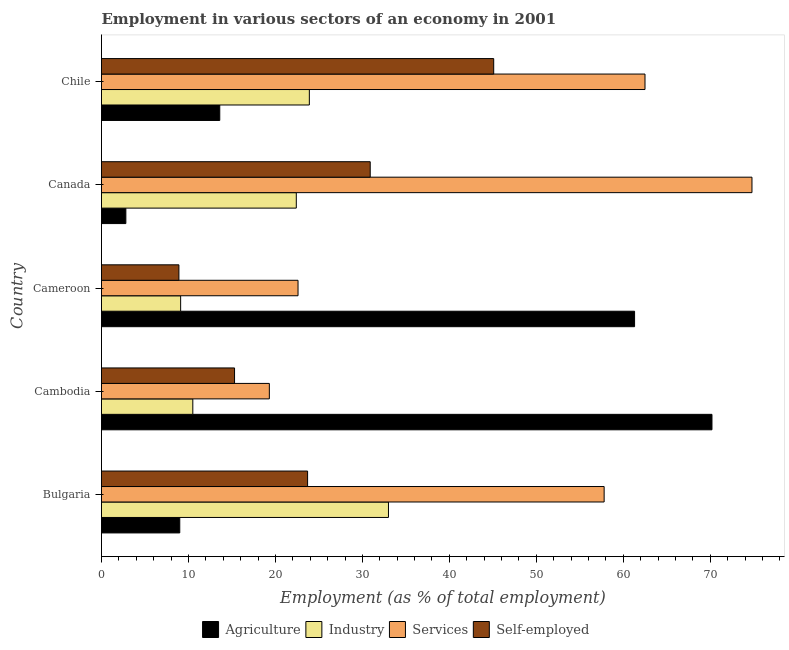How many groups of bars are there?
Your answer should be compact. 5. Are the number of bars per tick equal to the number of legend labels?
Your answer should be very brief. Yes. Are the number of bars on each tick of the Y-axis equal?
Provide a short and direct response. Yes. How many bars are there on the 2nd tick from the top?
Give a very brief answer. 4. In how many cases, is the number of bars for a given country not equal to the number of legend labels?
Your response must be concise. 0. What is the percentage of workers in industry in Cameroon?
Provide a succinct answer. 9.1. Across all countries, what is the minimum percentage of workers in services?
Keep it short and to the point. 19.3. In which country was the percentage of workers in services maximum?
Provide a succinct answer. Canada. What is the total percentage of self employed workers in the graph?
Give a very brief answer. 123.9. What is the difference between the percentage of self employed workers in Cambodia and that in Chile?
Your response must be concise. -29.8. What is the difference between the percentage of self employed workers in Cameroon and the percentage of workers in industry in Canada?
Provide a succinct answer. -13.5. What is the average percentage of self employed workers per country?
Your answer should be compact. 24.78. What is the difference between the percentage of self employed workers and percentage of workers in services in Bulgaria?
Your answer should be very brief. -34.1. In how many countries, is the percentage of workers in industry greater than 48 %?
Make the answer very short. 0. What is the ratio of the percentage of workers in industry in Cambodia to that in Canada?
Offer a very short reply. 0.47. Is the percentage of workers in services in Bulgaria less than that in Cambodia?
Your answer should be very brief. No. What is the difference between the highest and the second highest percentage of workers in industry?
Provide a short and direct response. 9.1. What is the difference between the highest and the lowest percentage of workers in agriculture?
Your answer should be very brief. 67.4. Is the sum of the percentage of workers in agriculture in Cambodia and Cameroon greater than the maximum percentage of workers in industry across all countries?
Offer a very short reply. Yes. What does the 3rd bar from the top in Cameroon represents?
Your answer should be very brief. Industry. What does the 4th bar from the bottom in Bulgaria represents?
Offer a terse response. Self-employed. Is it the case that in every country, the sum of the percentage of workers in agriculture and percentage of workers in industry is greater than the percentage of workers in services?
Your answer should be compact. No. How many bars are there?
Ensure brevity in your answer.  20. Are all the bars in the graph horizontal?
Offer a terse response. Yes. How many countries are there in the graph?
Offer a very short reply. 5. Does the graph contain any zero values?
Keep it short and to the point. No. Does the graph contain grids?
Provide a succinct answer. No. Where does the legend appear in the graph?
Make the answer very short. Bottom center. How many legend labels are there?
Offer a terse response. 4. How are the legend labels stacked?
Your answer should be compact. Horizontal. What is the title of the graph?
Offer a terse response. Employment in various sectors of an economy in 2001. What is the label or title of the X-axis?
Give a very brief answer. Employment (as % of total employment). What is the label or title of the Y-axis?
Your answer should be very brief. Country. What is the Employment (as % of total employment) of Agriculture in Bulgaria?
Your answer should be compact. 9. What is the Employment (as % of total employment) of Services in Bulgaria?
Provide a succinct answer. 57.8. What is the Employment (as % of total employment) of Self-employed in Bulgaria?
Keep it short and to the point. 23.7. What is the Employment (as % of total employment) of Agriculture in Cambodia?
Give a very brief answer. 70.2. What is the Employment (as % of total employment) in Industry in Cambodia?
Make the answer very short. 10.5. What is the Employment (as % of total employment) in Services in Cambodia?
Provide a succinct answer. 19.3. What is the Employment (as % of total employment) in Self-employed in Cambodia?
Provide a succinct answer. 15.3. What is the Employment (as % of total employment) of Agriculture in Cameroon?
Make the answer very short. 61.3. What is the Employment (as % of total employment) of Industry in Cameroon?
Give a very brief answer. 9.1. What is the Employment (as % of total employment) in Services in Cameroon?
Keep it short and to the point. 22.6. What is the Employment (as % of total employment) in Self-employed in Cameroon?
Your answer should be compact. 8.9. What is the Employment (as % of total employment) in Agriculture in Canada?
Make the answer very short. 2.8. What is the Employment (as % of total employment) in Industry in Canada?
Offer a very short reply. 22.4. What is the Employment (as % of total employment) of Services in Canada?
Make the answer very short. 74.8. What is the Employment (as % of total employment) of Self-employed in Canada?
Offer a terse response. 30.9. What is the Employment (as % of total employment) of Agriculture in Chile?
Ensure brevity in your answer.  13.6. What is the Employment (as % of total employment) in Industry in Chile?
Offer a very short reply. 23.9. What is the Employment (as % of total employment) in Services in Chile?
Ensure brevity in your answer.  62.5. What is the Employment (as % of total employment) in Self-employed in Chile?
Offer a very short reply. 45.1. Across all countries, what is the maximum Employment (as % of total employment) in Agriculture?
Make the answer very short. 70.2. Across all countries, what is the maximum Employment (as % of total employment) in Industry?
Provide a succinct answer. 33. Across all countries, what is the maximum Employment (as % of total employment) in Services?
Provide a short and direct response. 74.8. Across all countries, what is the maximum Employment (as % of total employment) in Self-employed?
Your answer should be compact. 45.1. Across all countries, what is the minimum Employment (as % of total employment) of Agriculture?
Ensure brevity in your answer.  2.8. Across all countries, what is the minimum Employment (as % of total employment) of Industry?
Offer a very short reply. 9.1. Across all countries, what is the minimum Employment (as % of total employment) of Services?
Make the answer very short. 19.3. Across all countries, what is the minimum Employment (as % of total employment) in Self-employed?
Provide a succinct answer. 8.9. What is the total Employment (as % of total employment) in Agriculture in the graph?
Keep it short and to the point. 156.9. What is the total Employment (as % of total employment) of Industry in the graph?
Provide a succinct answer. 98.9. What is the total Employment (as % of total employment) of Services in the graph?
Your answer should be very brief. 237. What is the total Employment (as % of total employment) of Self-employed in the graph?
Your answer should be very brief. 123.9. What is the difference between the Employment (as % of total employment) of Agriculture in Bulgaria and that in Cambodia?
Make the answer very short. -61.2. What is the difference between the Employment (as % of total employment) in Services in Bulgaria and that in Cambodia?
Make the answer very short. 38.5. What is the difference between the Employment (as % of total employment) of Agriculture in Bulgaria and that in Cameroon?
Provide a succinct answer. -52.3. What is the difference between the Employment (as % of total employment) of Industry in Bulgaria and that in Cameroon?
Offer a very short reply. 23.9. What is the difference between the Employment (as % of total employment) of Services in Bulgaria and that in Cameroon?
Provide a short and direct response. 35.2. What is the difference between the Employment (as % of total employment) of Self-employed in Bulgaria and that in Cameroon?
Your answer should be compact. 14.8. What is the difference between the Employment (as % of total employment) in Agriculture in Bulgaria and that in Canada?
Offer a terse response. 6.2. What is the difference between the Employment (as % of total employment) of Agriculture in Bulgaria and that in Chile?
Provide a succinct answer. -4.6. What is the difference between the Employment (as % of total employment) of Self-employed in Bulgaria and that in Chile?
Provide a succinct answer. -21.4. What is the difference between the Employment (as % of total employment) of Services in Cambodia and that in Cameroon?
Your answer should be very brief. -3.3. What is the difference between the Employment (as % of total employment) of Agriculture in Cambodia and that in Canada?
Ensure brevity in your answer.  67.4. What is the difference between the Employment (as % of total employment) of Services in Cambodia and that in Canada?
Your answer should be very brief. -55.5. What is the difference between the Employment (as % of total employment) of Self-employed in Cambodia and that in Canada?
Your answer should be compact. -15.6. What is the difference between the Employment (as % of total employment) of Agriculture in Cambodia and that in Chile?
Your response must be concise. 56.6. What is the difference between the Employment (as % of total employment) of Services in Cambodia and that in Chile?
Keep it short and to the point. -43.2. What is the difference between the Employment (as % of total employment) of Self-employed in Cambodia and that in Chile?
Your answer should be compact. -29.8. What is the difference between the Employment (as % of total employment) in Agriculture in Cameroon and that in Canada?
Keep it short and to the point. 58.5. What is the difference between the Employment (as % of total employment) of Services in Cameroon and that in Canada?
Keep it short and to the point. -52.2. What is the difference between the Employment (as % of total employment) in Agriculture in Cameroon and that in Chile?
Your answer should be compact. 47.7. What is the difference between the Employment (as % of total employment) in Industry in Cameroon and that in Chile?
Keep it short and to the point. -14.8. What is the difference between the Employment (as % of total employment) in Services in Cameroon and that in Chile?
Offer a terse response. -39.9. What is the difference between the Employment (as % of total employment) of Self-employed in Cameroon and that in Chile?
Offer a terse response. -36.2. What is the difference between the Employment (as % of total employment) in Industry in Canada and that in Chile?
Offer a very short reply. -1.5. What is the difference between the Employment (as % of total employment) in Self-employed in Canada and that in Chile?
Offer a terse response. -14.2. What is the difference between the Employment (as % of total employment) in Agriculture in Bulgaria and the Employment (as % of total employment) in Industry in Cambodia?
Make the answer very short. -1.5. What is the difference between the Employment (as % of total employment) of Agriculture in Bulgaria and the Employment (as % of total employment) of Services in Cambodia?
Your answer should be very brief. -10.3. What is the difference between the Employment (as % of total employment) of Industry in Bulgaria and the Employment (as % of total employment) of Services in Cambodia?
Your response must be concise. 13.7. What is the difference between the Employment (as % of total employment) in Services in Bulgaria and the Employment (as % of total employment) in Self-employed in Cambodia?
Your response must be concise. 42.5. What is the difference between the Employment (as % of total employment) of Agriculture in Bulgaria and the Employment (as % of total employment) of Industry in Cameroon?
Make the answer very short. -0.1. What is the difference between the Employment (as % of total employment) in Agriculture in Bulgaria and the Employment (as % of total employment) in Self-employed in Cameroon?
Give a very brief answer. 0.1. What is the difference between the Employment (as % of total employment) of Industry in Bulgaria and the Employment (as % of total employment) of Self-employed in Cameroon?
Provide a succinct answer. 24.1. What is the difference between the Employment (as % of total employment) of Services in Bulgaria and the Employment (as % of total employment) of Self-employed in Cameroon?
Offer a very short reply. 48.9. What is the difference between the Employment (as % of total employment) in Agriculture in Bulgaria and the Employment (as % of total employment) in Services in Canada?
Ensure brevity in your answer.  -65.8. What is the difference between the Employment (as % of total employment) in Agriculture in Bulgaria and the Employment (as % of total employment) in Self-employed in Canada?
Provide a short and direct response. -21.9. What is the difference between the Employment (as % of total employment) in Industry in Bulgaria and the Employment (as % of total employment) in Services in Canada?
Make the answer very short. -41.8. What is the difference between the Employment (as % of total employment) of Industry in Bulgaria and the Employment (as % of total employment) of Self-employed in Canada?
Provide a succinct answer. 2.1. What is the difference between the Employment (as % of total employment) of Services in Bulgaria and the Employment (as % of total employment) of Self-employed in Canada?
Keep it short and to the point. 26.9. What is the difference between the Employment (as % of total employment) of Agriculture in Bulgaria and the Employment (as % of total employment) of Industry in Chile?
Give a very brief answer. -14.9. What is the difference between the Employment (as % of total employment) in Agriculture in Bulgaria and the Employment (as % of total employment) in Services in Chile?
Your answer should be very brief. -53.5. What is the difference between the Employment (as % of total employment) of Agriculture in Bulgaria and the Employment (as % of total employment) of Self-employed in Chile?
Keep it short and to the point. -36.1. What is the difference between the Employment (as % of total employment) of Industry in Bulgaria and the Employment (as % of total employment) of Services in Chile?
Your answer should be very brief. -29.5. What is the difference between the Employment (as % of total employment) of Agriculture in Cambodia and the Employment (as % of total employment) of Industry in Cameroon?
Keep it short and to the point. 61.1. What is the difference between the Employment (as % of total employment) in Agriculture in Cambodia and the Employment (as % of total employment) in Services in Cameroon?
Offer a very short reply. 47.6. What is the difference between the Employment (as % of total employment) of Agriculture in Cambodia and the Employment (as % of total employment) of Self-employed in Cameroon?
Provide a short and direct response. 61.3. What is the difference between the Employment (as % of total employment) of Services in Cambodia and the Employment (as % of total employment) of Self-employed in Cameroon?
Keep it short and to the point. 10.4. What is the difference between the Employment (as % of total employment) in Agriculture in Cambodia and the Employment (as % of total employment) in Industry in Canada?
Your answer should be very brief. 47.8. What is the difference between the Employment (as % of total employment) of Agriculture in Cambodia and the Employment (as % of total employment) of Services in Canada?
Provide a short and direct response. -4.6. What is the difference between the Employment (as % of total employment) of Agriculture in Cambodia and the Employment (as % of total employment) of Self-employed in Canada?
Ensure brevity in your answer.  39.3. What is the difference between the Employment (as % of total employment) of Industry in Cambodia and the Employment (as % of total employment) of Services in Canada?
Keep it short and to the point. -64.3. What is the difference between the Employment (as % of total employment) in Industry in Cambodia and the Employment (as % of total employment) in Self-employed in Canada?
Offer a terse response. -20.4. What is the difference between the Employment (as % of total employment) in Agriculture in Cambodia and the Employment (as % of total employment) in Industry in Chile?
Make the answer very short. 46.3. What is the difference between the Employment (as % of total employment) in Agriculture in Cambodia and the Employment (as % of total employment) in Self-employed in Chile?
Offer a terse response. 25.1. What is the difference between the Employment (as % of total employment) in Industry in Cambodia and the Employment (as % of total employment) in Services in Chile?
Offer a very short reply. -52. What is the difference between the Employment (as % of total employment) in Industry in Cambodia and the Employment (as % of total employment) in Self-employed in Chile?
Provide a succinct answer. -34.6. What is the difference between the Employment (as % of total employment) in Services in Cambodia and the Employment (as % of total employment) in Self-employed in Chile?
Provide a short and direct response. -25.8. What is the difference between the Employment (as % of total employment) in Agriculture in Cameroon and the Employment (as % of total employment) in Industry in Canada?
Your answer should be compact. 38.9. What is the difference between the Employment (as % of total employment) of Agriculture in Cameroon and the Employment (as % of total employment) of Self-employed in Canada?
Provide a short and direct response. 30.4. What is the difference between the Employment (as % of total employment) of Industry in Cameroon and the Employment (as % of total employment) of Services in Canada?
Your response must be concise. -65.7. What is the difference between the Employment (as % of total employment) of Industry in Cameroon and the Employment (as % of total employment) of Self-employed in Canada?
Provide a succinct answer. -21.8. What is the difference between the Employment (as % of total employment) in Services in Cameroon and the Employment (as % of total employment) in Self-employed in Canada?
Provide a short and direct response. -8.3. What is the difference between the Employment (as % of total employment) of Agriculture in Cameroon and the Employment (as % of total employment) of Industry in Chile?
Provide a short and direct response. 37.4. What is the difference between the Employment (as % of total employment) in Agriculture in Cameroon and the Employment (as % of total employment) in Services in Chile?
Ensure brevity in your answer.  -1.2. What is the difference between the Employment (as % of total employment) of Industry in Cameroon and the Employment (as % of total employment) of Services in Chile?
Your response must be concise. -53.4. What is the difference between the Employment (as % of total employment) of Industry in Cameroon and the Employment (as % of total employment) of Self-employed in Chile?
Provide a succinct answer. -36. What is the difference between the Employment (as % of total employment) in Services in Cameroon and the Employment (as % of total employment) in Self-employed in Chile?
Your answer should be compact. -22.5. What is the difference between the Employment (as % of total employment) in Agriculture in Canada and the Employment (as % of total employment) in Industry in Chile?
Provide a succinct answer. -21.1. What is the difference between the Employment (as % of total employment) of Agriculture in Canada and the Employment (as % of total employment) of Services in Chile?
Your answer should be compact. -59.7. What is the difference between the Employment (as % of total employment) in Agriculture in Canada and the Employment (as % of total employment) in Self-employed in Chile?
Your response must be concise. -42.3. What is the difference between the Employment (as % of total employment) in Industry in Canada and the Employment (as % of total employment) in Services in Chile?
Give a very brief answer. -40.1. What is the difference between the Employment (as % of total employment) in Industry in Canada and the Employment (as % of total employment) in Self-employed in Chile?
Ensure brevity in your answer.  -22.7. What is the difference between the Employment (as % of total employment) of Services in Canada and the Employment (as % of total employment) of Self-employed in Chile?
Provide a short and direct response. 29.7. What is the average Employment (as % of total employment) of Agriculture per country?
Provide a short and direct response. 31.38. What is the average Employment (as % of total employment) in Industry per country?
Provide a short and direct response. 19.78. What is the average Employment (as % of total employment) in Services per country?
Your answer should be compact. 47.4. What is the average Employment (as % of total employment) of Self-employed per country?
Your answer should be very brief. 24.78. What is the difference between the Employment (as % of total employment) of Agriculture and Employment (as % of total employment) of Industry in Bulgaria?
Make the answer very short. -24. What is the difference between the Employment (as % of total employment) of Agriculture and Employment (as % of total employment) of Services in Bulgaria?
Your answer should be compact. -48.8. What is the difference between the Employment (as % of total employment) of Agriculture and Employment (as % of total employment) of Self-employed in Bulgaria?
Your answer should be compact. -14.7. What is the difference between the Employment (as % of total employment) of Industry and Employment (as % of total employment) of Services in Bulgaria?
Keep it short and to the point. -24.8. What is the difference between the Employment (as % of total employment) of Services and Employment (as % of total employment) of Self-employed in Bulgaria?
Make the answer very short. 34.1. What is the difference between the Employment (as % of total employment) of Agriculture and Employment (as % of total employment) of Industry in Cambodia?
Your response must be concise. 59.7. What is the difference between the Employment (as % of total employment) in Agriculture and Employment (as % of total employment) in Services in Cambodia?
Your answer should be compact. 50.9. What is the difference between the Employment (as % of total employment) of Agriculture and Employment (as % of total employment) of Self-employed in Cambodia?
Offer a very short reply. 54.9. What is the difference between the Employment (as % of total employment) of Industry and Employment (as % of total employment) of Self-employed in Cambodia?
Offer a terse response. -4.8. What is the difference between the Employment (as % of total employment) in Services and Employment (as % of total employment) in Self-employed in Cambodia?
Ensure brevity in your answer.  4. What is the difference between the Employment (as % of total employment) in Agriculture and Employment (as % of total employment) in Industry in Cameroon?
Your answer should be compact. 52.2. What is the difference between the Employment (as % of total employment) in Agriculture and Employment (as % of total employment) in Services in Cameroon?
Your answer should be very brief. 38.7. What is the difference between the Employment (as % of total employment) of Agriculture and Employment (as % of total employment) of Self-employed in Cameroon?
Your answer should be compact. 52.4. What is the difference between the Employment (as % of total employment) in Industry and Employment (as % of total employment) in Services in Cameroon?
Make the answer very short. -13.5. What is the difference between the Employment (as % of total employment) in Services and Employment (as % of total employment) in Self-employed in Cameroon?
Ensure brevity in your answer.  13.7. What is the difference between the Employment (as % of total employment) of Agriculture and Employment (as % of total employment) of Industry in Canada?
Keep it short and to the point. -19.6. What is the difference between the Employment (as % of total employment) of Agriculture and Employment (as % of total employment) of Services in Canada?
Ensure brevity in your answer.  -72. What is the difference between the Employment (as % of total employment) of Agriculture and Employment (as % of total employment) of Self-employed in Canada?
Your response must be concise. -28.1. What is the difference between the Employment (as % of total employment) of Industry and Employment (as % of total employment) of Services in Canada?
Your answer should be compact. -52.4. What is the difference between the Employment (as % of total employment) in Services and Employment (as % of total employment) in Self-employed in Canada?
Provide a succinct answer. 43.9. What is the difference between the Employment (as % of total employment) of Agriculture and Employment (as % of total employment) of Industry in Chile?
Offer a very short reply. -10.3. What is the difference between the Employment (as % of total employment) of Agriculture and Employment (as % of total employment) of Services in Chile?
Provide a succinct answer. -48.9. What is the difference between the Employment (as % of total employment) in Agriculture and Employment (as % of total employment) in Self-employed in Chile?
Offer a terse response. -31.5. What is the difference between the Employment (as % of total employment) in Industry and Employment (as % of total employment) in Services in Chile?
Your answer should be very brief. -38.6. What is the difference between the Employment (as % of total employment) of Industry and Employment (as % of total employment) of Self-employed in Chile?
Your answer should be compact. -21.2. What is the ratio of the Employment (as % of total employment) in Agriculture in Bulgaria to that in Cambodia?
Your answer should be compact. 0.13. What is the ratio of the Employment (as % of total employment) of Industry in Bulgaria to that in Cambodia?
Provide a succinct answer. 3.14. What is the ratio of the Employment (as % of total employment) in Services in Bulgaria to that in Cambodia?
Make the answer very short. 2.99. What is the ratio of the Employment (as % of total employment) of Self-employed in Bulgaria to that in Cambodia?
Offer a very short reply. 1.55. What is the ratio of the Employment (as % of total employment) in Agriculture in Bulgaria to that in Cameroon?
Keep it short and to the point. 0.15. What is the ratio of the Employment (as % of total employment) of Industry in Bulgaria to that in Cameroon?
Make the answer very short. 3.63. What is the ratio of the Employment (as % of total employment) of Services in Bulgaria to that in Cameroon?
Make the answer very short. 2.56. What is the ratio of the Employment (as % of total employment) of Self-employed in Bulgaria to that in Cameroon?
Your answer should be compact. 2.66. What is the ratio of the Employment (as % of total employment) of Agriculture in Bulgaria to that in Canada?
Ensure brevity in your answer.  3.21. What is the ratio of the Employment (as % of total employment) in Industry in Bulgaria to that in Canada?
Your answer should be very brief. 1.47. What is the ratio of the Employment (as % of total employment) of Services in Bulgaria to that in Canada?
Offer a terse response. 0.77. What is the ratio of the Employment (as % of total employment) of Self-employed in Bulgaria to that in Canada?
Offer a very short reply. 0.77. What is the ratio of the Employment (as % of total employment) of Agriculture in Bulgaria to that in Chile?
Your response must be concise. 0.66. What is the ratio of the Employment (as % of total employment) of Industry in Bulgaria to that in Chile?
Make the answer very short. 1.38. What is the ratio of the Employment (as % of total employment) of Services in Bulgaria to that in Chile?
Offer a terse response. 0.92. What is the ratio of the Employment (as % of total employment) in Self-employed in Bulgaria to that in Chile?
Provide a succinct answer. 0.53. What is the ratio of the Employment (as % of total employment) of Agriculture in Cambodia to that in Cameroon?
Offer a very short reply. 1.15. What is the ratio of the Employment (as % of total employment) in Industry in Cambodia to that in Cameroon?
Offer a terse response. 1.15. What is the ratio of the Employment (as % of total employment) in Services in Cambodia to that in Cameroon?
Your response must be concise. 0.85. What is the ratio of the Employment (as % of total employment) of Self-employed in Cambodia to that in Cameroon?
Your answer should be very brief. 1.72. What is the ratio of the Employment (as % of total employment) of Agriculture in Cambodia to that in Canada?
Offer a terse response. 25.07. What is the ratio of the Employment (as % of total employment) in Industry in Cambodia to that in Canada?
Ensure brevity in your answer.  0.47. What is the ratio of the Employment (as % of total employment) of Services in Cambodia to that in Canada?
Your answer should be very brief. 0.26. What is the ratio of the Employment (as % of total employment) of Self-employed in Cambodia to that in Canada?
Make the answer very short. 0.5. What is the ratio of the Employment (as % of total employment) in Agriculture in Cambodia to that in Chile?
Provide a short and direct response. 5.16. What is the ratio of the Employment (as % of total employment) in Industry in Cambodia to that in Chile?
Provide a short and direct response. 0.44. What is the ratio of the Employment (as % of total employment) of Services in Cambodia to that in Chile?
Your answer should be very brief. 0.31. What is the ratio of the Employment (as % of total employment) of Self-employed in Cambodia to that in Chile?
Provide a short and direct response. 0.34. What is the ratio of the Employment (as % of total employment) of Agriculture in Cameroon to that in Canada?
Your answer should be very brief. 21.89. What is the ratio of the Employment (as % of total employment) of Industry in Cameroon to that in Canada?
Your answer should be very brief. 0.41. What is the ratio of the Employment (as % of total employment) in Services in Cameroon to that in Canada?
Provide a succinct answer. 0.3. What is the ratio of the Employment (as % of total employment) in Self-employed in Cameroon to that in Canada?
Give a very brief answer. 0.29. What is the ratio of the Employment (as % of total employment) of Agriculture in Cameroon to that in Chile?
Give a very brief answer. 4.51. What is the ratio of the Employment (as % of total employment) of Industry in Cameroon to that in Chile?
Give a very brief answer. 0.38. What is the ratio of the Employment (as % of total employment) of Services in Cameroon to that in Chile?
Ensure brevity in your answer.  0.36. What is the ratio of the Employment (as % of total employment) of Self-employed in Cameroon to that in Chile?
Your response must be concise. 0.2. What is the ratio of the Employment (as % of total employment) of Agriculture in Canada to that in Chile?
Offer a very short reply. 0.21. What is the ratio of the Employment (as % of total employment) in Industry in Canada to that in Chile?
Make the answer very short. 0.94. What is the ratio of the Employment (as % of total employment) of Services in Canada to that in Chile?
Provide a short and direct response. 1.2. What is the ratio of the Employment (as % of total employment) of Self-employed in Canada to that in Chile?
Provide a short and direct response. 0.69. What is the difference between the highest and the second highest Employment (as % of total employment) in Industry?
Make the answer very short. 9.1. What is the difference between the highest and the lowest Employment (as % of total employment) of Agriculture?
Ensure brevity in your answer.  67.4. What is the difference between the highest and the lowest Employment (as % of total employment) of Industry?
Ensure brevity in your answer.  23.9. What is the difference between the highest and the lowest Employment (as % of total employment) in Services?
Make the answer very short. 55.5. What is the difference between the highest and the lowest Employment (as % of total employment) in Self-employed?
Provide a succinct answer. 36.2. 